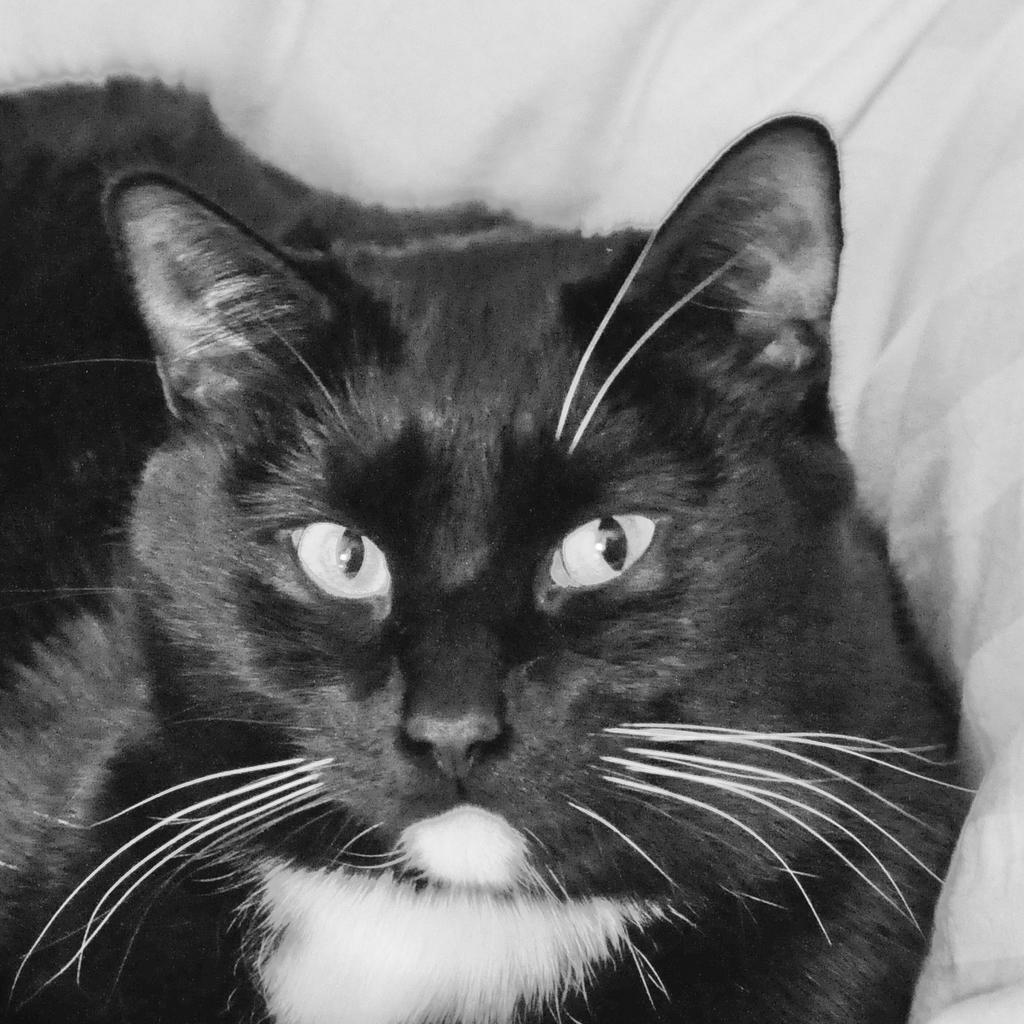What type of animal is in the image? There is a cat in the image. What color scheme is used in the image? The image is black and white. What can be seen in the background of the image? There is cloth visible in the background of the image. Where is the stick located in the image? There is no stick present in the image. What type of volcano can be seen in the background of the image? There is no volcano present in the image; it features a cat and cloth in a black and white color scheme. 